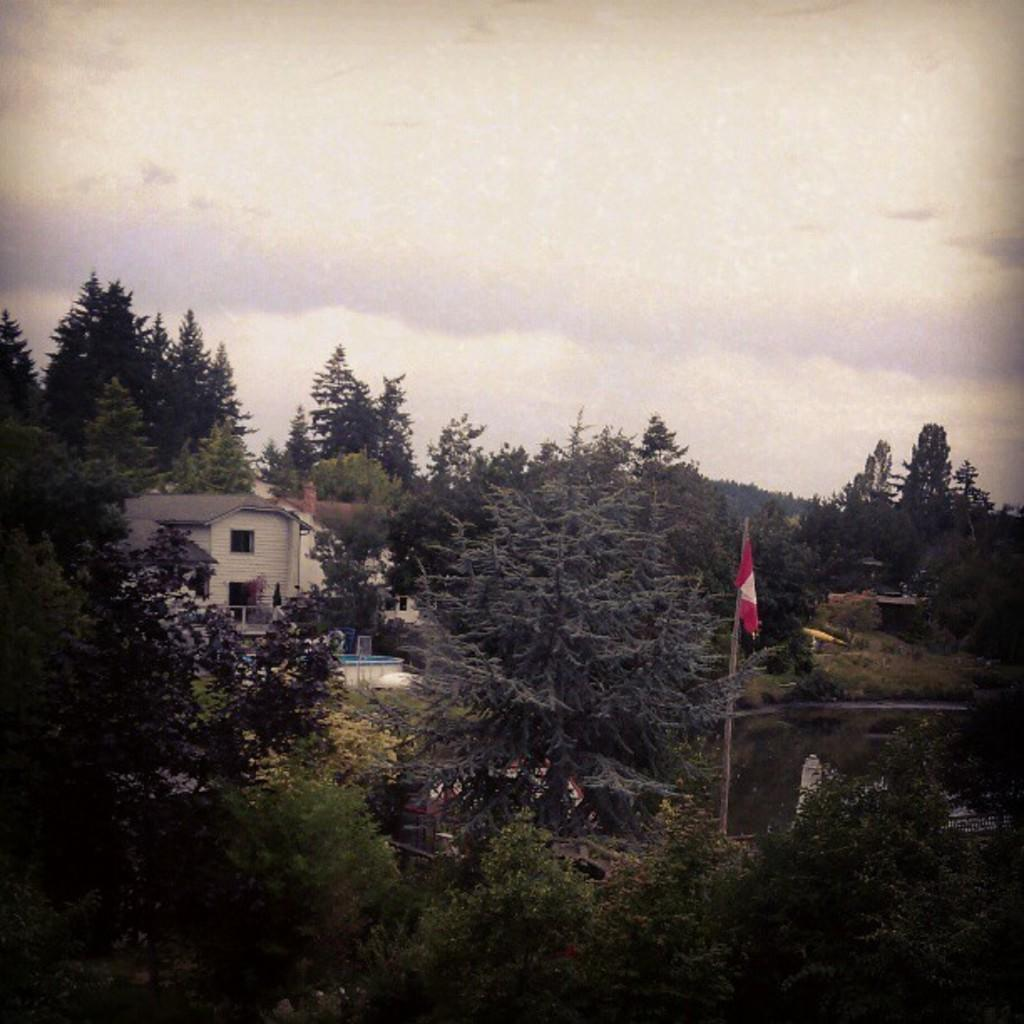What type of vegetation can be seen in the image? There are trees in the image. Where is the flag located in the image? The flag is on the right side of the image. What structure is located on the left side of the image? There is a house on the left side of the image. What can be seen in the sky in the background of the image? There are clouds in the sky in the background of the image. What type of linen is draped over the trees in the image? There is no linen draped over the trees in the image; only trees are present. Can you hear the song being sung by the trees in the image? There is no song being sung by the trees in the image; it is a still image with no sound. 